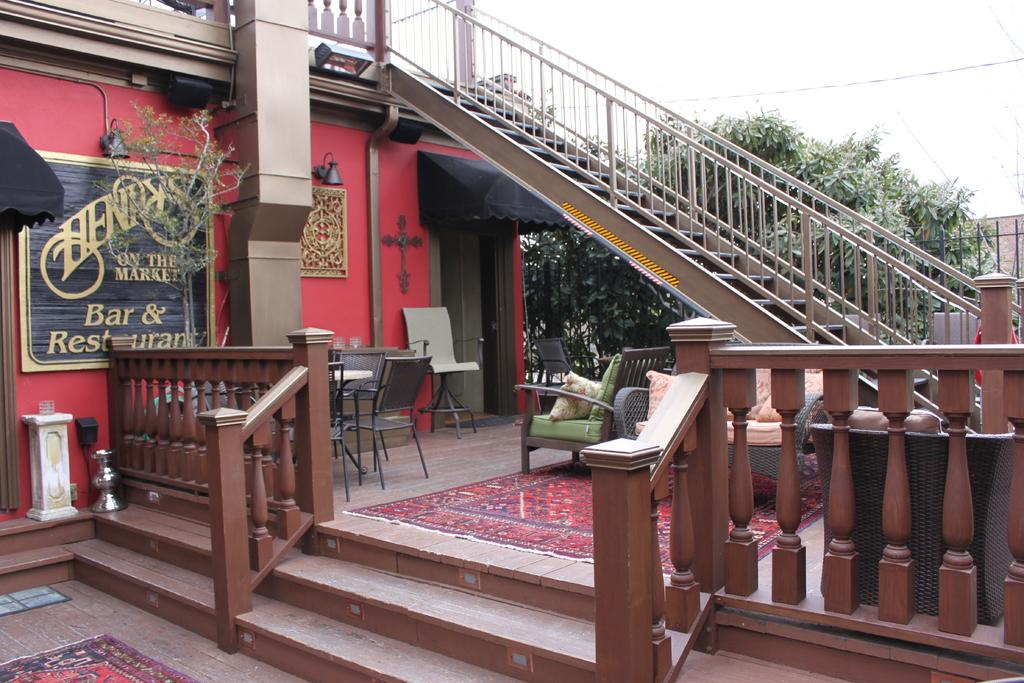What type of structure can be seen in the image? There are stairs in the image. What natural elements are present in the image? There are trees in the image. What signage is visible in the image? There is a name board in the image. What type of decorative element is present in the image? There is a frame in the image. What type of lighting is present in the image? There are lights in the image. What type of furniture is present in the image? There is a sofa and a table with chairs in the image. What type of floor covering is present in the image? There are carpets in the image. What type of barrier is present in the image? There is a black color fence in the image. What is the tendency of the fang in the image? There is no fang present in the image. What type of sort can be seen in the image? There is no sort present in the image. 